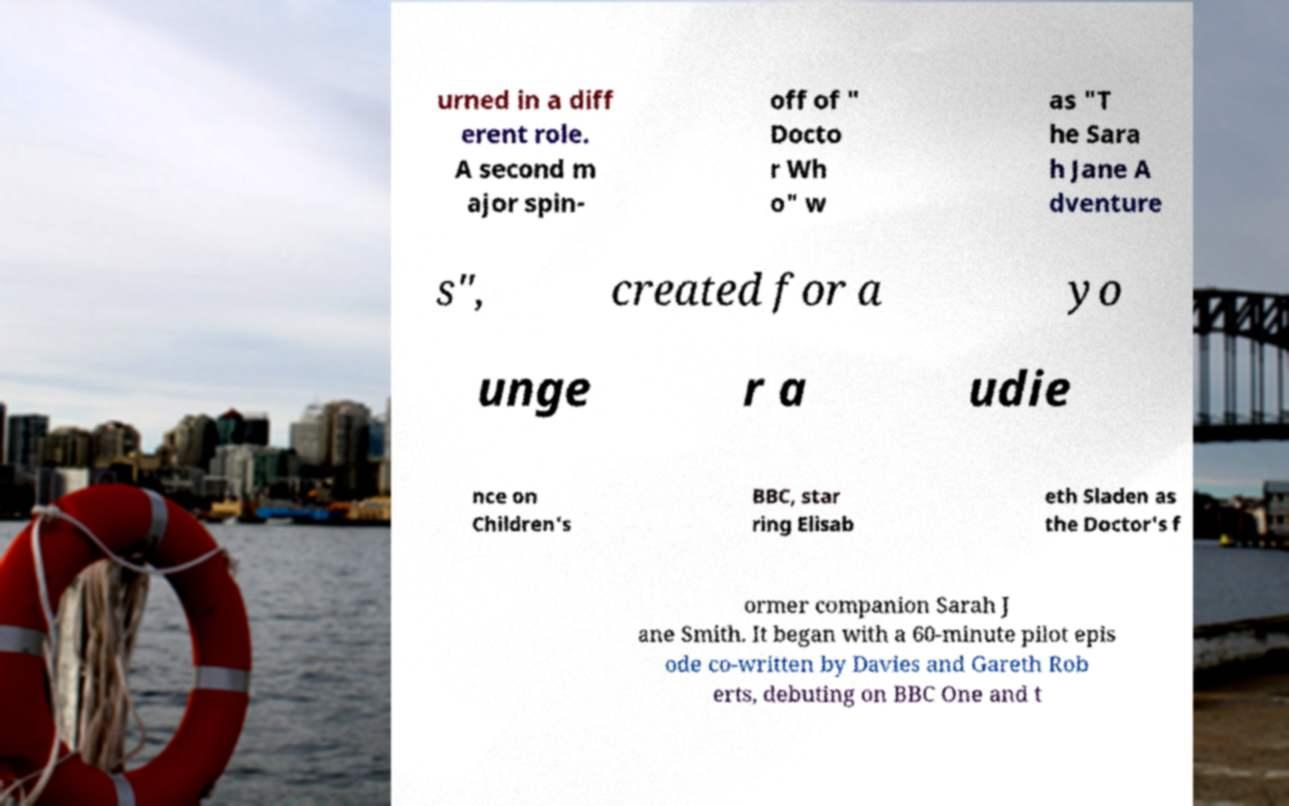There's text embedded in this image that I need extracted. Can you transcribe it verbatim? urned in a diff erent role. A second m ajor spin- off of " Docto r Wh o" w as "T he Sara h Jane A dventure s", created for a yo unge r a udie nce on Children's BBC, star ring Elisab eth Sladen as the Doctor's f ormer companion Sarah J ane Smith. It began with a 60-minute pilot epis ode co-written by Davies and Gareth Rob erts, debuting on BBC One and t 